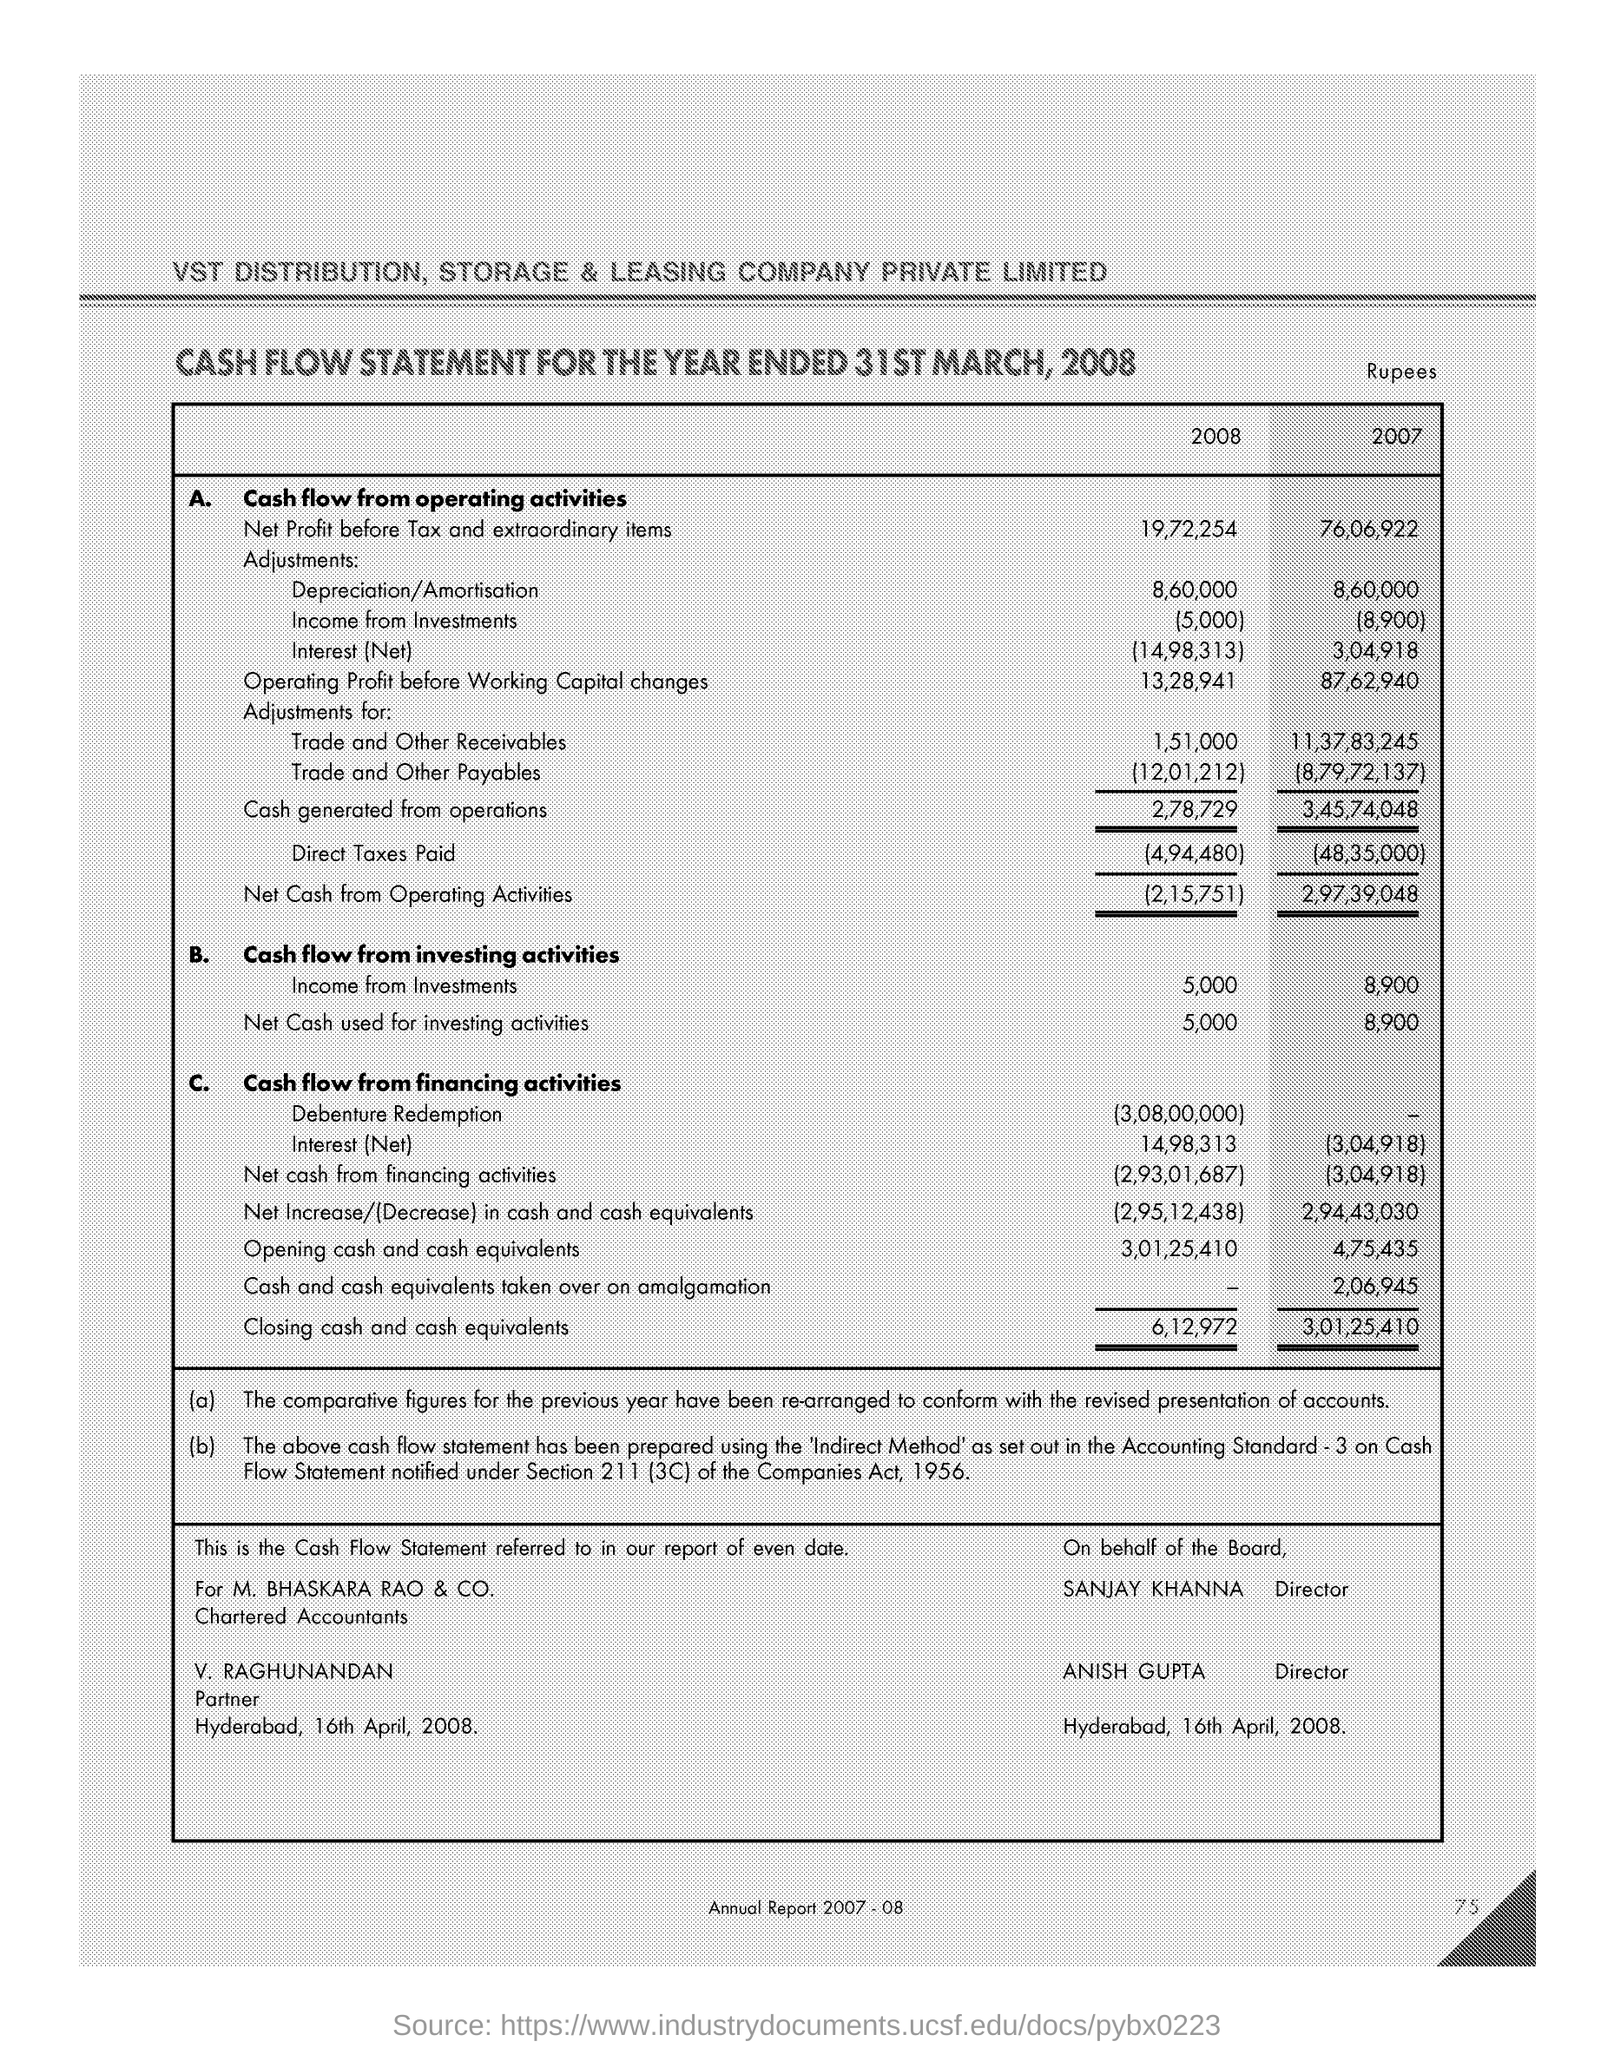Outline some significant characteristics in this image. The net profit before tax and extraordinary items for the year 2007 was 76,06,922. 